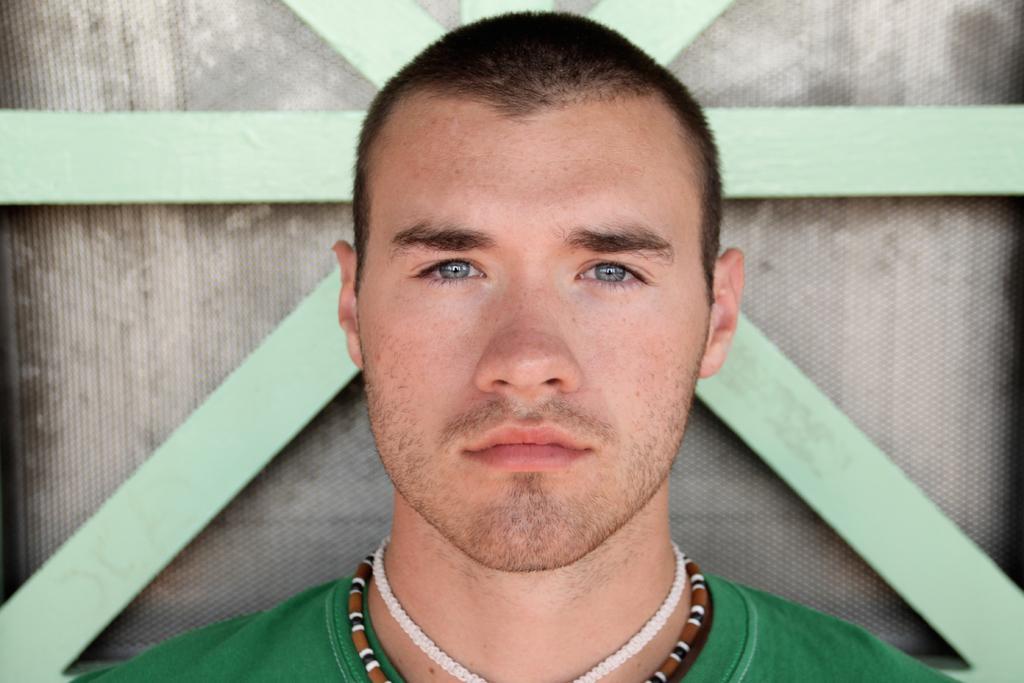Describe this image in one or two sentences. In the middle of the image, there is a person with a green color T-shirt, watching something. In the background, there is a fence. Beside this fence, there is an object. 